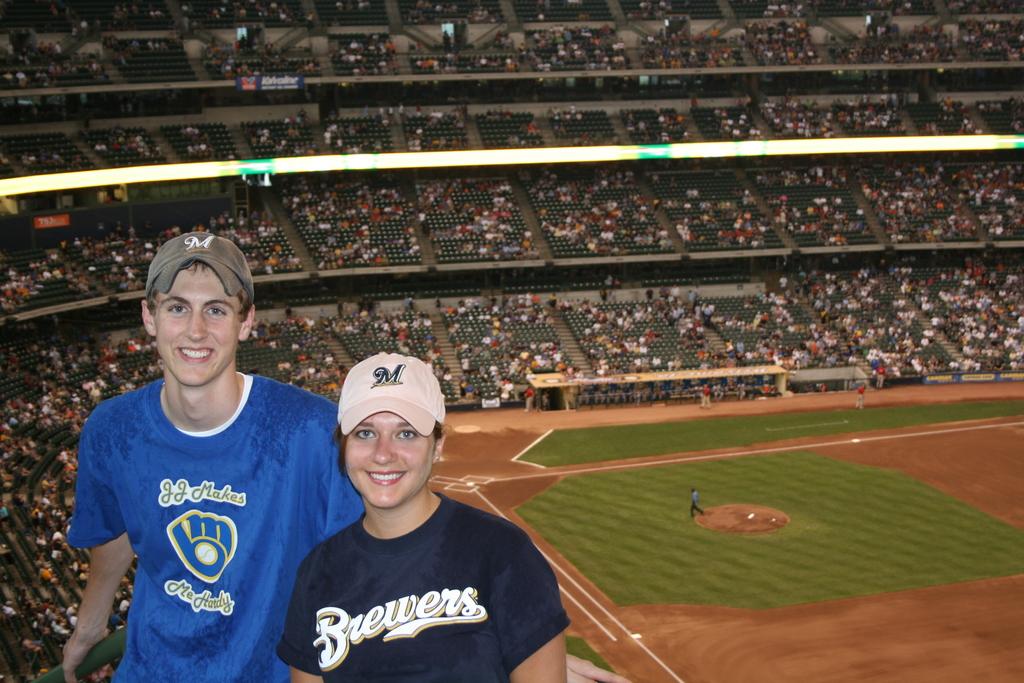What team name is on the womans shirt?
Provide a succinct answer. Brewers. What letter is on the lady's hat?
Provide a succinct answer. M. 